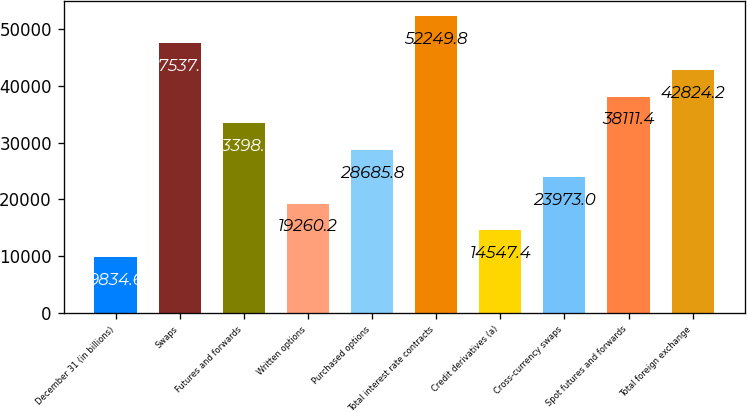<chart> <loc_0><loc_0><loc_500><loc_500><bar_chart><fcel>December 31 (in billions)<fcel>Swaps<fcel>Futures and forwards<fcel>Written options<fcel>Purchased options<fcel>Total interest rate contracts<fcel>Credit derivatives (a)<fcel>Cross-currency swaps<fcel>Spot futures and forwards<fcel>Total foreign exchange<nl><fcel>9834.6<fcel>47537<fcel>33398.6<fcel>19260.2<fcel>28685.8<fcel>52249.8<fcel>14547.4<fcel>23973<fcel>38111.4<fcel>42824.2<nl></chart> 